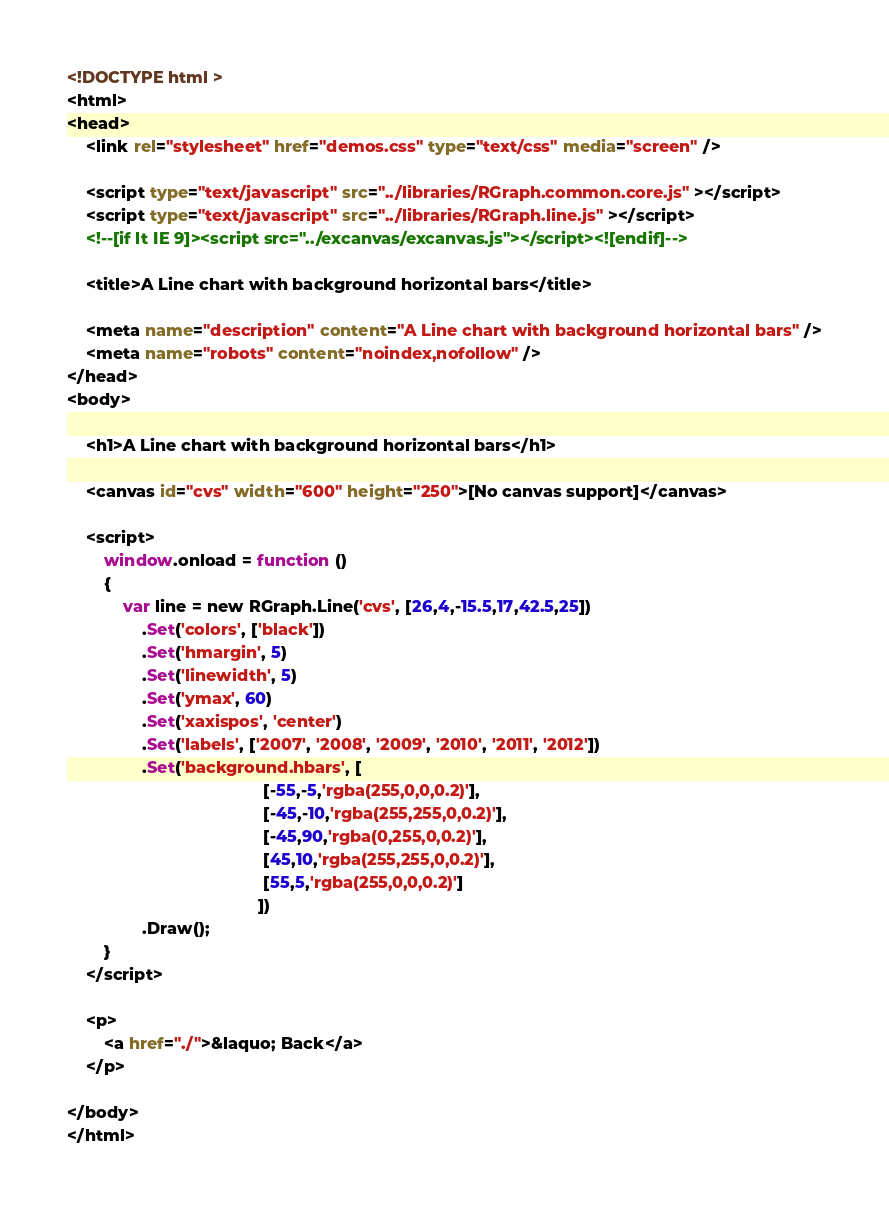Convert code to text. <code><loc_0><loc_0><loc_500><loc_500><_HTML_><!DOCTYPE html >
<html>
<head>
    <link rel="stylesheet" href="demos.css" type="text/css" media="screen" />
    
    <script type="text/javascript" src="../libraries/RGraph.common.core.js" ></script>
    <script type="text/javascript" src="../libraries/RGraph.line.js" ></script>
    <!--[if lt IE 9]><script src="../excanvas/excanvas.js"></script><![endif]-->
    
    <title>A Line chart with background horizontal bars</title>
    
    <meta name="description" content="A Line chart with background horizontal bars" />
    <meta name="robots" content="noindex,nofollow" />
</head>
<body>

    <h1>A Line chart with background horizontal bars</h1>

    <canvas id="cvs" width="600" height="250">[No canvas support]</canvas>

    <script>
        window.onload = function ()
        {
            var line = new RGraph.Line('cvs', [26,4,-15.5,17,42.5,25])
                .Set('colors', ['black'])
                .Set('hmargin', 5)
                .Set('linewidth', 5)
                .Set('ymax', 60)
                .Set('xaxispos', 'center')
                .Set('labels', ['2007', '2008', '2009', '2010', '2011', '2012'])
                .Set('background.hbars', [
                                          [-55,-5,'rgba(255,0,0,0.2)'],
                                          [-45,-10,'rgba(255,255,0,0.2)'],
                                          [-45,90,'rgba(0,255,0,0.2)'],
                                          [45,10,'rgba(255,255,0,0.2)'],
                                          [55,5,'rgba(255,0,0,0.2)']
                                         ])
                .Draw();
        }
    </script>

    <p>
        <a href="./">&laquo; Back</a>
    </p>

</body>
</html></code> 